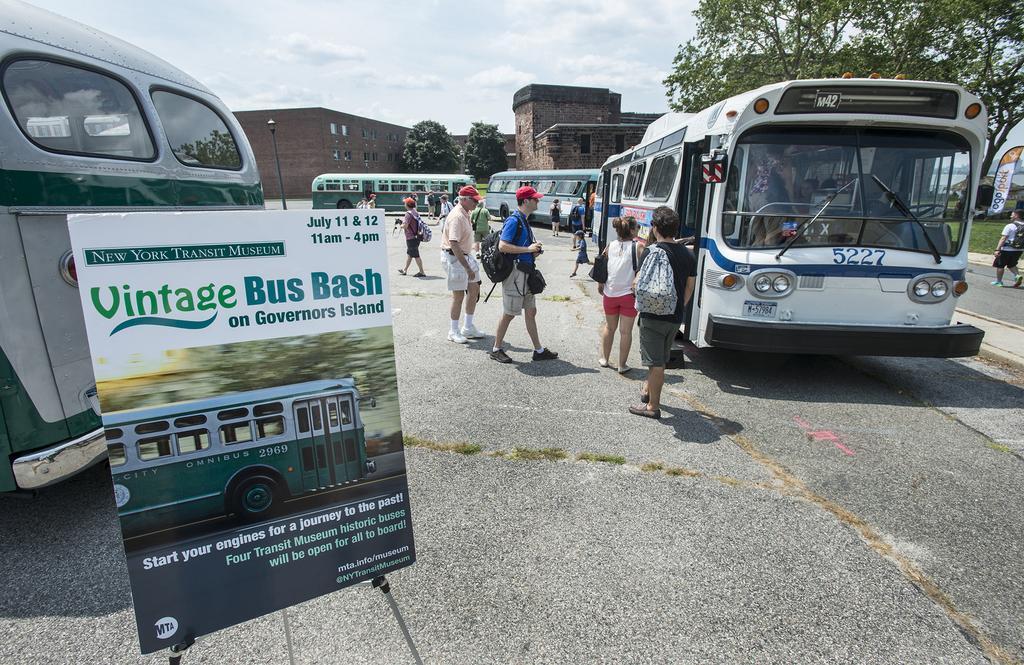Describe this image in one or two sentences. There are buses, banner, people are standing wearing bags. There is a pole, trees and buildings at the back. 